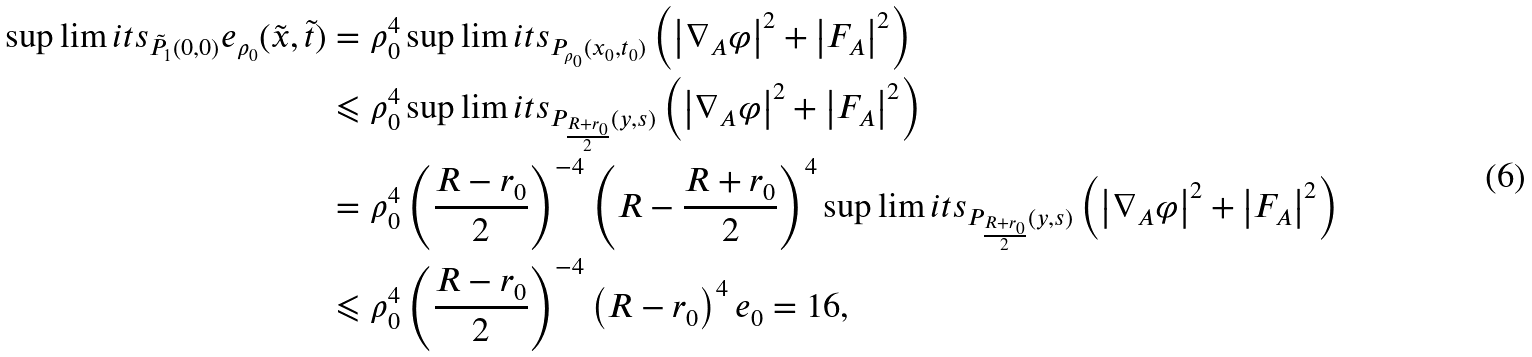<formula> <loc_0><loc_0><loc_500><loc_500>\sup \lim i t s _ { \tilde { P } _ { 1 } ( 0 , 0 ) } e _ { \rho _ { 0 } } ( \tilde { x } , \tilde { t } ) & = \rho _ { 0 } ^ { 4 } \sup \lim i t s _ { P _ { \rho _ { 0 } } ( x _ { 0 } , t _ { 0 } ) } \left ( { \left | { \nabla _ { A } \varphi } \right | ^ { 2 } + \left | { F _ { A } } \right | ^ { 2 } } \right ) \\ & \leqslant \rho _ { 0 } ^ { 4 } \sup \lim i t s _ { P _ { \frac { R + r _ { 0 } } { 2 } } ( y , s ) } \left ( { \left | { \nabla _ { A } \varphi } \right | ^ { 2 } + \left | { F _ { A } } \right | ^ { 2 } } \right ) \\ & = \rho _ { 0 } ^ { 4 } \left ( { \frac { R - r _ { 0 } } { 2 } } \right ) ^ { - 4 } \left ( { R - \frac { R + r _ { 0 } } { 2 } } \right ) ^ { 4 } \sup \lim i t s _ { P _ { \frac { R + r _ { 0 } } { 2 } } ( y , s ) } \left ( { \left | { \nabla _ { A } \varphi } \right | ^ { 2 } + \left | { F _ { A } } \right | ^ { 2 } } \right ) \\ & \leqslant \rho _ { 0 } ^ { 4 } \left ( { \frac { R - r _ { 0 } } { 2 } } \right ) ^ { - 4 } \left ( { R - r _ { 0 } } \right ) ^ { 4 } e _ { 0 } = 1 6 , \\</formula> 